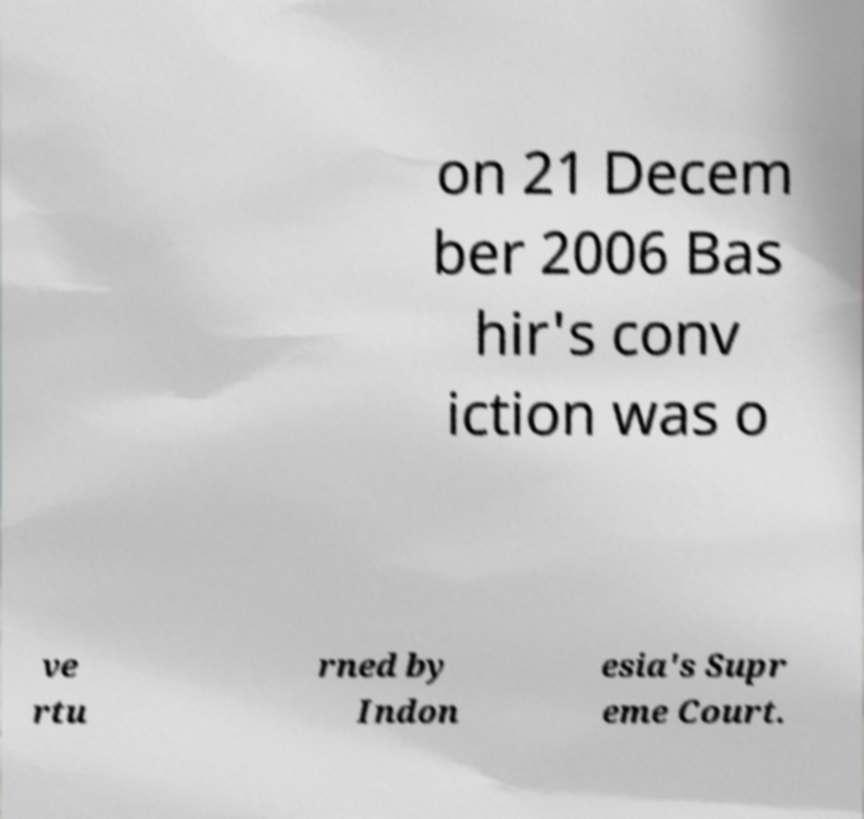Could you assist in decoding the text presented in this image and type it out clearly? on 21 Decem ber 2006 Bas hir's conv iction was o ve rtu rned by Indon esia's Supr eme Court. 